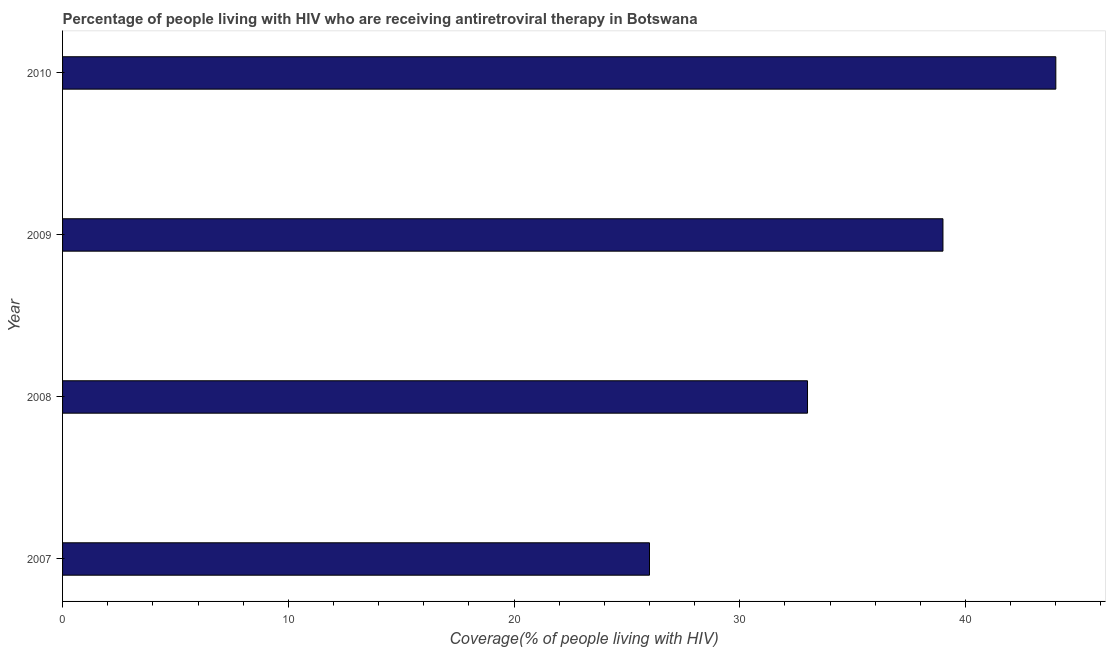Does the graph contain any zero values?
Ensure brevity in your answer.  No. Does the graph contain grids?
Make the answer very short. No. What is the title of the graph?
Your answer should be compact. Percentage of people living with HIV who are receiving antiretroviral therapy in Botswana. What is the label or title of the X-axis?
Give a very brief answer. Coverage(% of people living with HIV). What is the label or title of the Y-axis?
Ensure brevity in your answer.  Year. What is the antiretroviral therapy coverage in 2010?
Keep it short and to the point. 44. Across all years, what is the minimum antiretroviral therapy coverage?
Keep it short and to the point. 26. What is the sum of the antiretroviral therapy coverage?
Your answer should be very brief. 142. What is the median antiretroviral therapy coverage?
Make the answer very short. 36. In how many years, is the antiretroviral therapy coverage greater than 32 %?
Ensure brevity in your answer.  3. Do a majority of the years between 2008 and 2007 (inclusive) have antiretroviral therapy coverage greater than 4 %?
Keep it short and to the point. No. What is the ratio of the antiretroviral therapy coverage in 2007 to that in 2008?
Give a very brief answer. 0.79. Is the antiretroviral therapy coverage in 2007 less than that in 2009?
Your answer should be very brief. Yes. Is the difference between the antiretroviral therapy coverage in 2009 and 2010 greater than the difference between any two years?
Provide a succinct answer. No. What is the difference between the highest and the second highest antiretroviral therapy coverage?
Make the answer very short. 5. Is the sum of the antiretroviral therapy coverage in 2008 and 2010 greater than the maximum antiretroviral therapy coverage across all years?
Keep it short and to the point. Yes. In how many years, is the antiretroviral therapy coverage greater than the average antiretroviral therapy coverage taken over all years?
Provide a succinct answer. 2. How many bars are there?
Your answer should be compact. 4. Are all the bars in the graph horizontal?
Offer a terse response. Yes. How many years are there in the graph?
Your answer should be compact. 4. Are the values on the major ticks of X-axis written in scientific E-notation?
Give a very brief answer. No. What is the Coverage(% of people living with HIV) in 2010?
Provide a succinct answer. 44. What is the difference between the Coverage(% of people living with HIV) in 2007 and 2008?
Offer a terse response. -7. What is the difference between the Coverage(% of people living with HIV) in 2007 and 2010?
Offer a terse response. -18. What is the difference between the Coverage(% of people living with HIV) in 2009 and 2010?
Give a very brief answer. -5. What is the ratio of the Coverage(% of people living with HIV) in 2007 to that in 2008?
Provide a short and direct response. 0.79. What is the ratio of the Coverage(% of people living with HIV) in 2007 to that in 2009?
Offer a terse response. 0.67. What is the ratio of the Coverage(% of people living with HIV) in 2007 to that in 2010?
Your response must be concise. 0.59. What is the ratio of the Coverage(% of people living with HIV) in 2008 to that in 2009?
Provide a succinct answer. 0.85. What is the ratio of the Coverage(% of people living with HIV) in 2008 to that in 2010?
Provide a succinct answer. 0.75. What is the ratio of the Coverage(% of people living with HIV) in 2009 to that in 2010?
Ensure brevity in your answer.  0.89. 